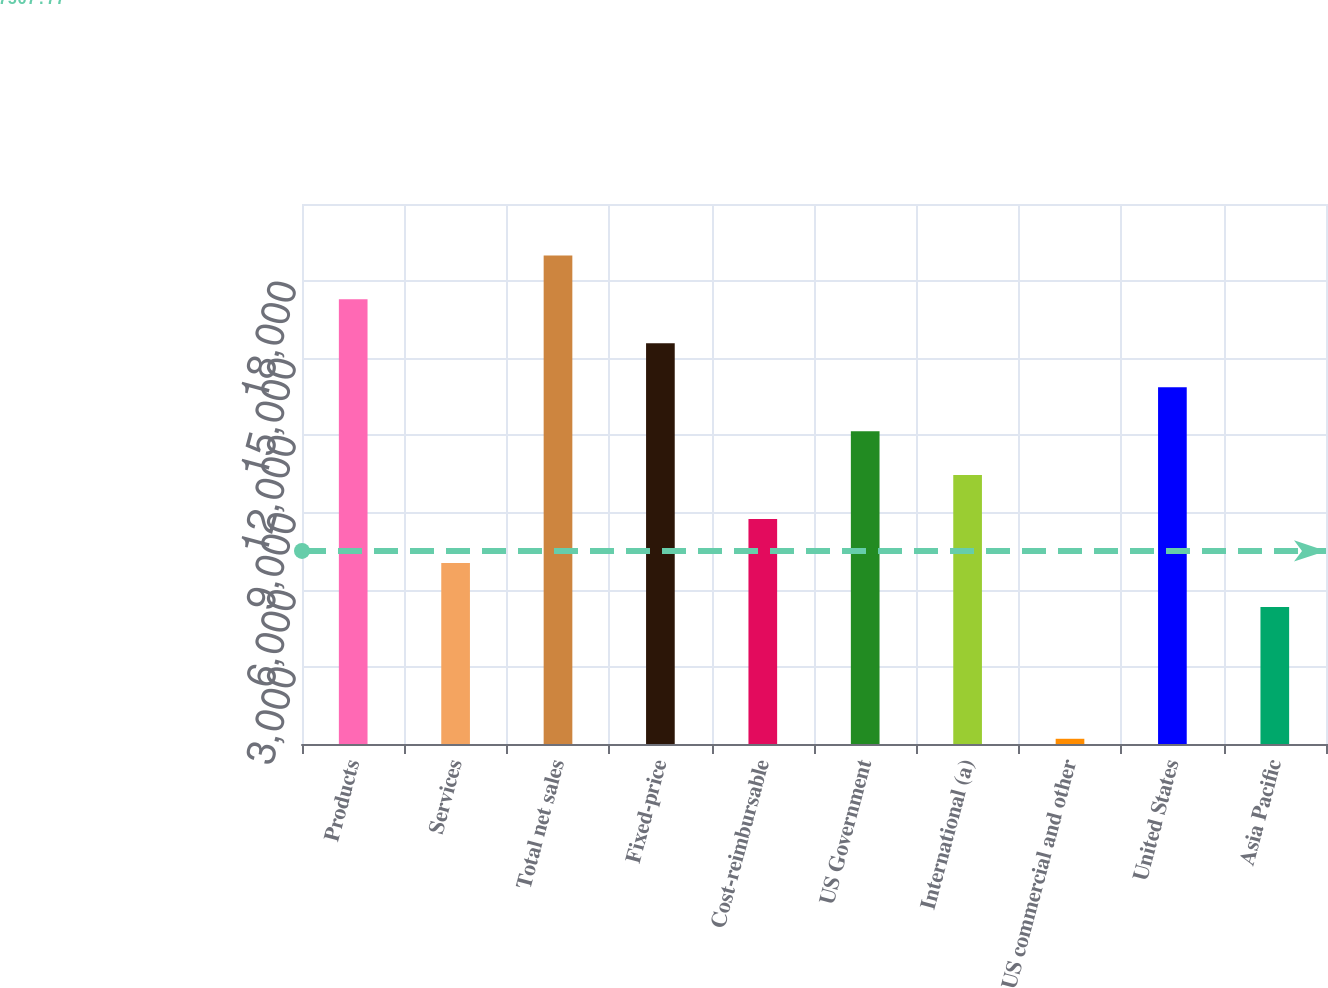Convert chart. <chart><loc_0><loc_0><loc_500><loc_500><bar_chart><fcel>Products<fcel>Services<fcel>Total net sales<fcel>Fixed-price<fcel>Cost-reimbursable<fcel>US Government<fcel>International (a)<fcel>US commercial and other<fcel>United States<fcel>Asia Pacific<nl><fcel>17293<fcel>7039<fcel>19002<fcel>15584<fcel>8748<fcel>12166<fcel>10457<fcel>203<fcel>13875<fcel>5330<nl></chart> 